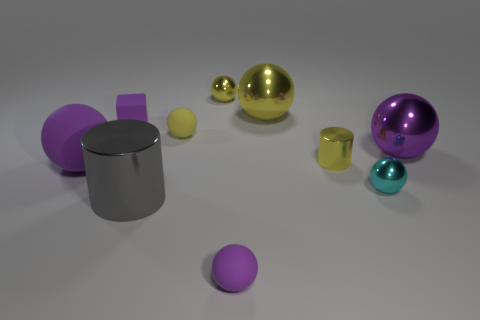Are there the same number of small purple things behind the tiny cyan metal sphere and small purple rubber things?
Make the answer very short. No. Do the small rubber object that is in front of the gray cylinder and the small matte cube have the same color?
Provide a succinct answer. Yes. There is a purple sphere that is both right of the large gray thing and behind the gray thing; what is its material?
Offer a terse response. Metal. Are there any purple rubber objects to the right of the purple rubber sphere that is behind the cyan shiny ball?
Offer a terse response. Yes. Does the large gray cylinder have the same material as the small block?
Make the answer very short. No. What is the shape of the matte object that is both left of the large gray shiny thing and in front of the big purple metal ball?
Offer a terse response. Sphere. There is a purple thing that is behind the large metal ball that is on the right side of the big yellow metal sphere; what size is it?
Keep it short and to the point. Small. What number of big rubber objects have the same shape as the purple shiny thing?
Your response must be concise. 1. Does the block have the same color as the big rubber object?
Make the answer very short. Yes. Is there any other thing that has the same shape as the tiny cyan object?
Keep it short and to the point. Yes. 